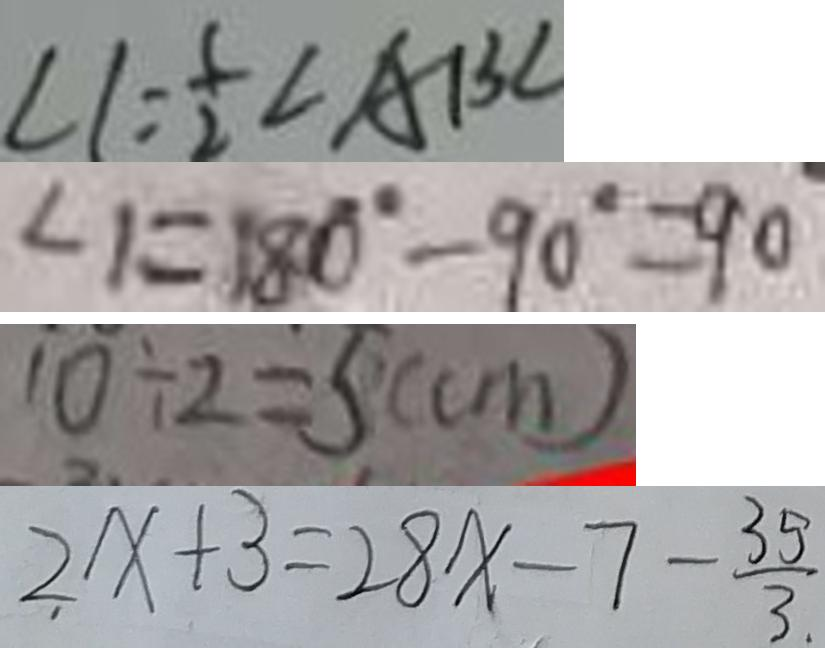<formula> <loc_0><loc_0><loc_500><loc_500>\angle 1 = \frac { 1 } { 2 } \angle A B C 
 \angle 1 = 1 8 0 ^ { \circ } - 9 0 ^ { \circ } = 9 0 ^ { \circ } 
 1 0 \div 2 = 5 ( c m ) 
 2 x + 3 = 2 8 x - 7 - \frac { 3 5 } { 3 }</formula> 